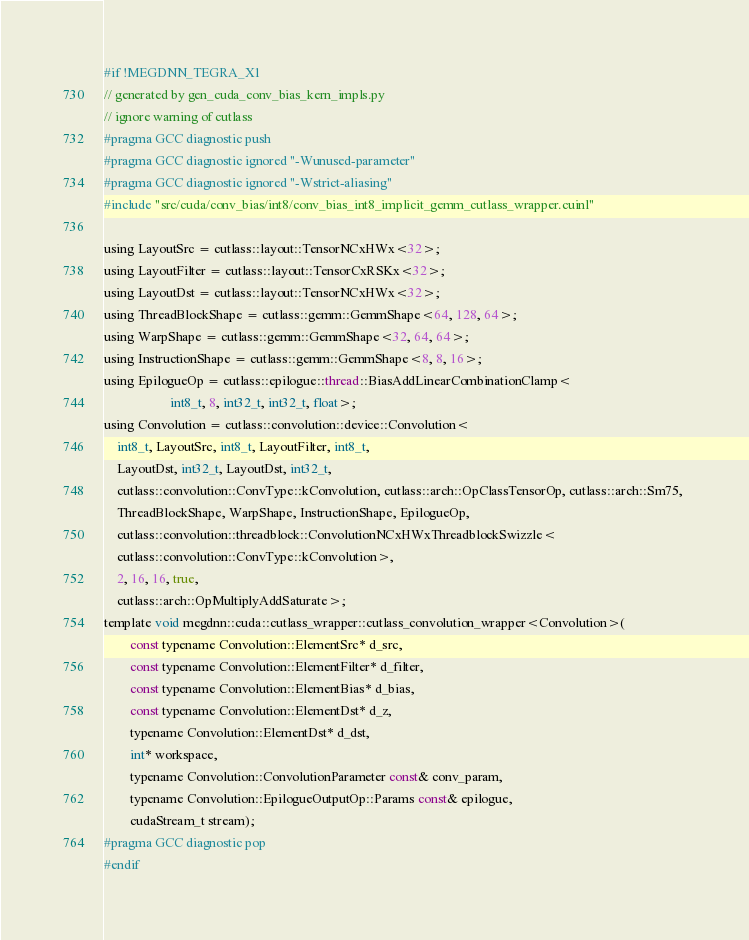Convert code to text. <code><loc_0><loc_0><loc_500><loc_500><_Cuda_>#if !MEGDNN_TEGRA_X1
// generated by gen_cuda_conv_bias_kern_impls.py
// ignore warning of cutlass
#pragma GCC diagnostic push
#pragma GCC diagnostic ignored "-Wunused-parameter"
#pragma GCC diagnostic ignored "-Wstrict-aliasing"
#include "src/cuda/conv_bias/int8/conv_bias_int8_implicit_gemm_cutlass_wrapper.cuinl"

using LayoutSrc = cutlass::layout::TensorNCxHWx<32>;
using LayoutFilter = cutlass::layout::TensorCxRSKx<32>;
using LayoutDst = cutlass::layout::TensorNCxHWx<32>;
using ThreadBlockShape = cutlass::gemm::GemmShape<64, 128, 64>;
using WarpShape = cutlass::gemm::GemmShape<32, 64, 64>;
using InstructionShape = cutlass::gemm::GemmShape<8, 8, 16>;
using EpilogueOp = cutlass::epilogue::thread::BiasAddLinearCombinationClamp<
                    int8_t, 8, int32_t, int32_t, float>;
using Convolution = cutlass::convolution::device::Convolution<
    int8_t, LayoutSrc, int8_t, LayoutFilter, int8_t, 
    LayoutDst, int32_t, LayoutDst, int32_t, 
    cutlass::convolution::ConvType::kConvolution, cutlass::arch::OpClassTensorOp, cutlass::arch::Sm75, 
    ThreadBlockShape, WarpShape, InstructionShape, EpilogueOp, 
    cutlass::convolution::threadblock::ConvolutionNCxHWxThreadblockSwizzle<
    cutlass::convolution::ConvType::kConvolution>, 
    2, 16, 16, true, 
    cutlass::arch::OpMultiplyAddSaturate>;
template void megdnn::cuda::cutlass_wrapper::cutlass_convolution_wrapper<Convolution>(
        const typename Convolution::ElementSrc* d_src, 
        const typename Convolution::ElementFilter* d_filter, 
        const typename Convolution::ElementBias* d_bias, 
        const typename Convolution::ElementDst* d_z, 
        typename Convolution::ElementDst* d_dst, 
        int* workspace, 
        typename Convolution::ConvolutionParameter const& conv_param, 
        typename Convolution::EpilogueOutputOp::Params const& epilogue, 
        cudaStream_t stream);
#pragma GCC diagnostic pop
#endif
</code> 